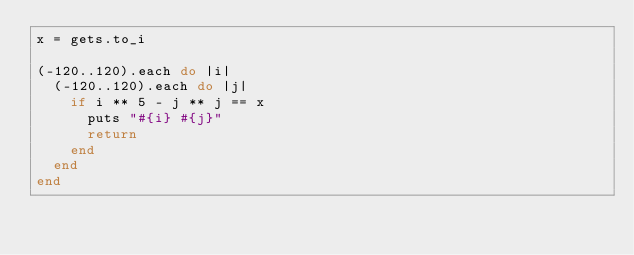<code> <loc_0><loc_0><loc_500><loc_500><_Ruby_>x = gets.to_i

(-120..120).each do |i|
  (-120..120).each do |j|
    if i ** 5 - j ** j == x
      puts "#{i} #{j}" 
      return
    end
  end
end
</code> 